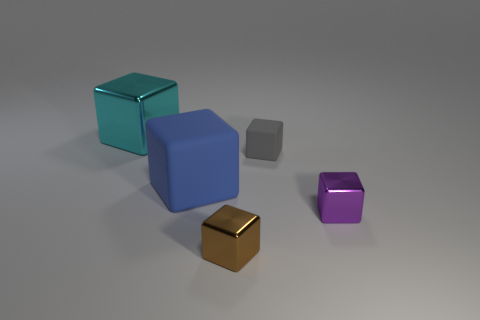Are there any tiny gray objects behind the object behind the matte cube that is behind the blue cube? No, there are no tiny gray objects in the described location. The space behind the matte cube, which itself is behind the blue cube, is clear of any objects, tiny and gray or otherwise. 